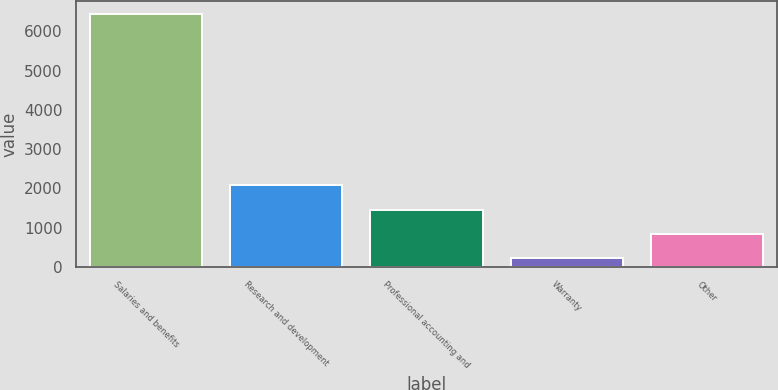Convert chart to OTSL. <chart><loc_0><loc_0><loc_500><loc_500><bar_chart><fcel>Salaries and benefits<fcel>Research and development<fcel>Professional accounting and<fcel>Warranty<fcel>Other<nl><fcel>6443<fcel>2082.7<fcel>1459.8<fcel>214<fcel>836.9<nl></chart> 